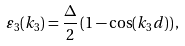Convert formula to latex. <formula><loc_0><loc_0><loc_500><loc_500>\varepsilon _ { 3 } ( k _ { 3 } ) = { \frac { \Delta } { 2 } } \left ( 1 - \cos ( k _ { 3 } d ) \right ) ,</formula> 